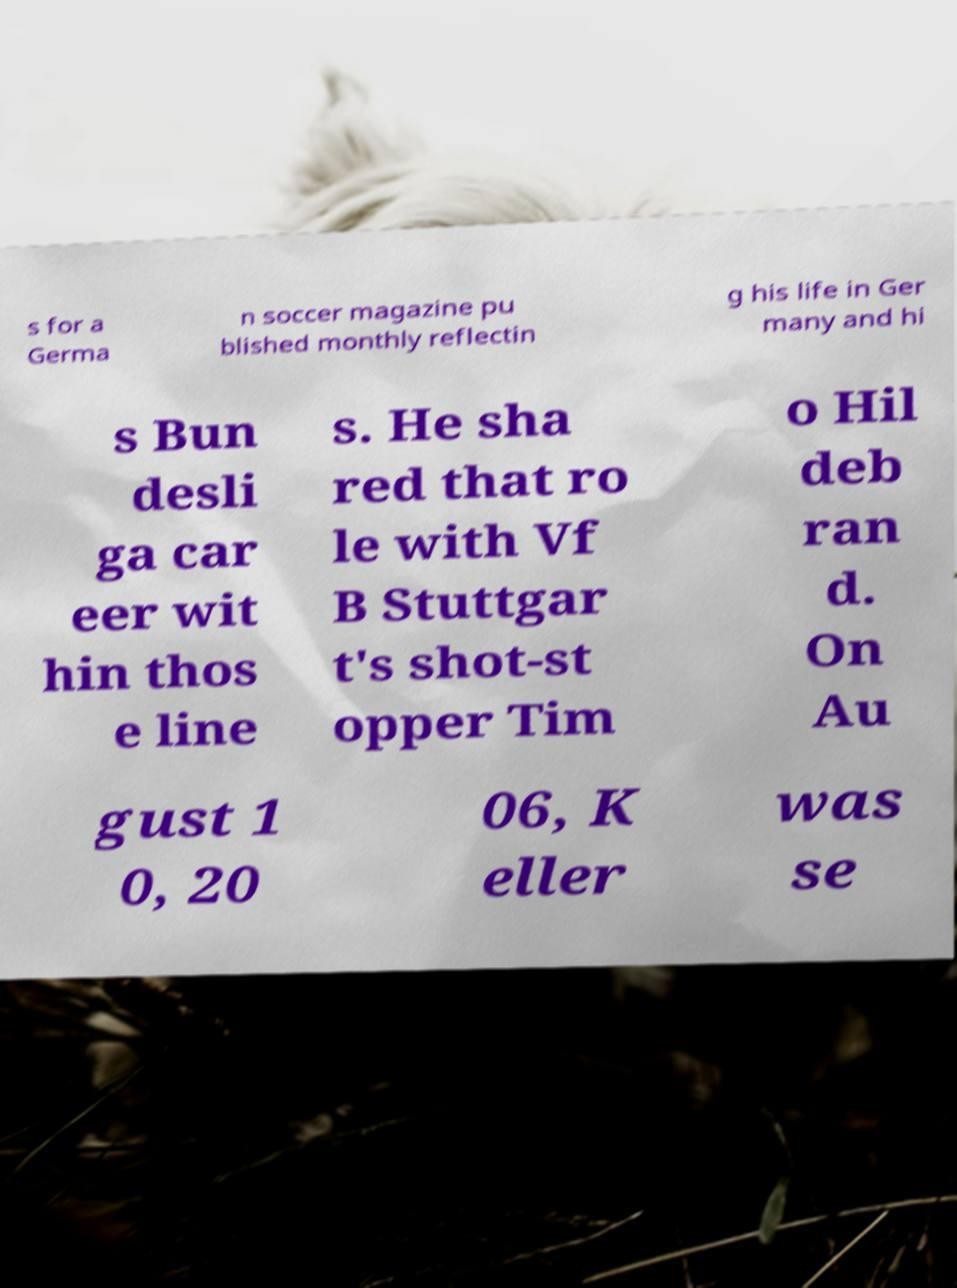What messages or text are displayed in this image? I need them in a readable, typed format. s for a Germa n soccer magazine pu blished monthly reflectin g his life in Ger many and hi s Bun desli ga car eer wit hin thos e line s. He sha red that ro le with Vf B Stuttgar t's shot-st opper Tim o Hil deb ran d. On Au gust 1 0, 20 06, K eller was se 